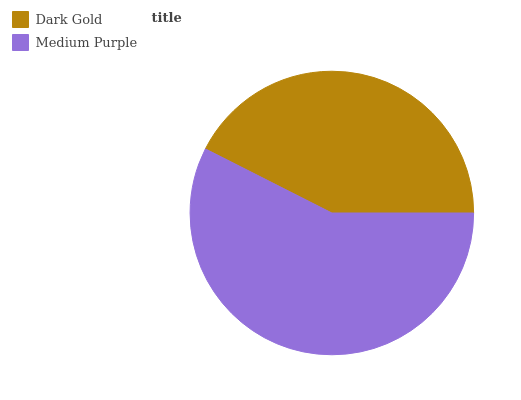Is Dark Gold the minimum?
Answer yes or no. Yes. Is Medium Purple the maximum?
Answer yes or no. Yes. Is Medium Purple the minimum?
Answer yes or no. No. Is Medium Purple greater than Dark Gold?
Answer yes or no. Yes. Is Dark Gold less than Medium Purple?
Answer yes or no. Yes. Is Dark Gold greater than Medium Purple?
Answer yes or no. No. Is Medium Purple less than Dark Gold?
Answer yes or no. No. Is Medium Purple the high median?
Answer yes or no. Yes. Is Dark Gold the low median?
Answer yes or no. Yes. Is Dark Gold the high median?
Answer yes or no. No. Is Medium Purple the low median?
Answer yes or no. No. 